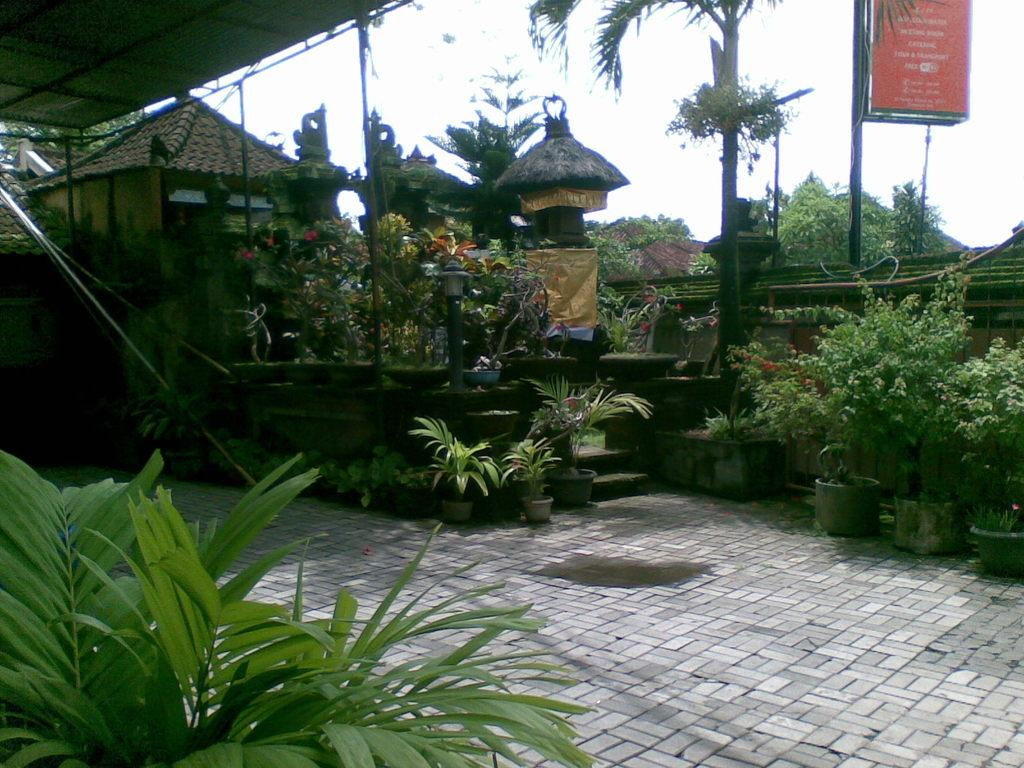What type of plants can be seen in the image? There are plants in different pots on the ground. What can be seen in the background of the image? There are buildings, trees, a shed, and the sky visible in the background of the image. What type of rock is being used to express love in the image? There is no rock or expression of love present in the image. 